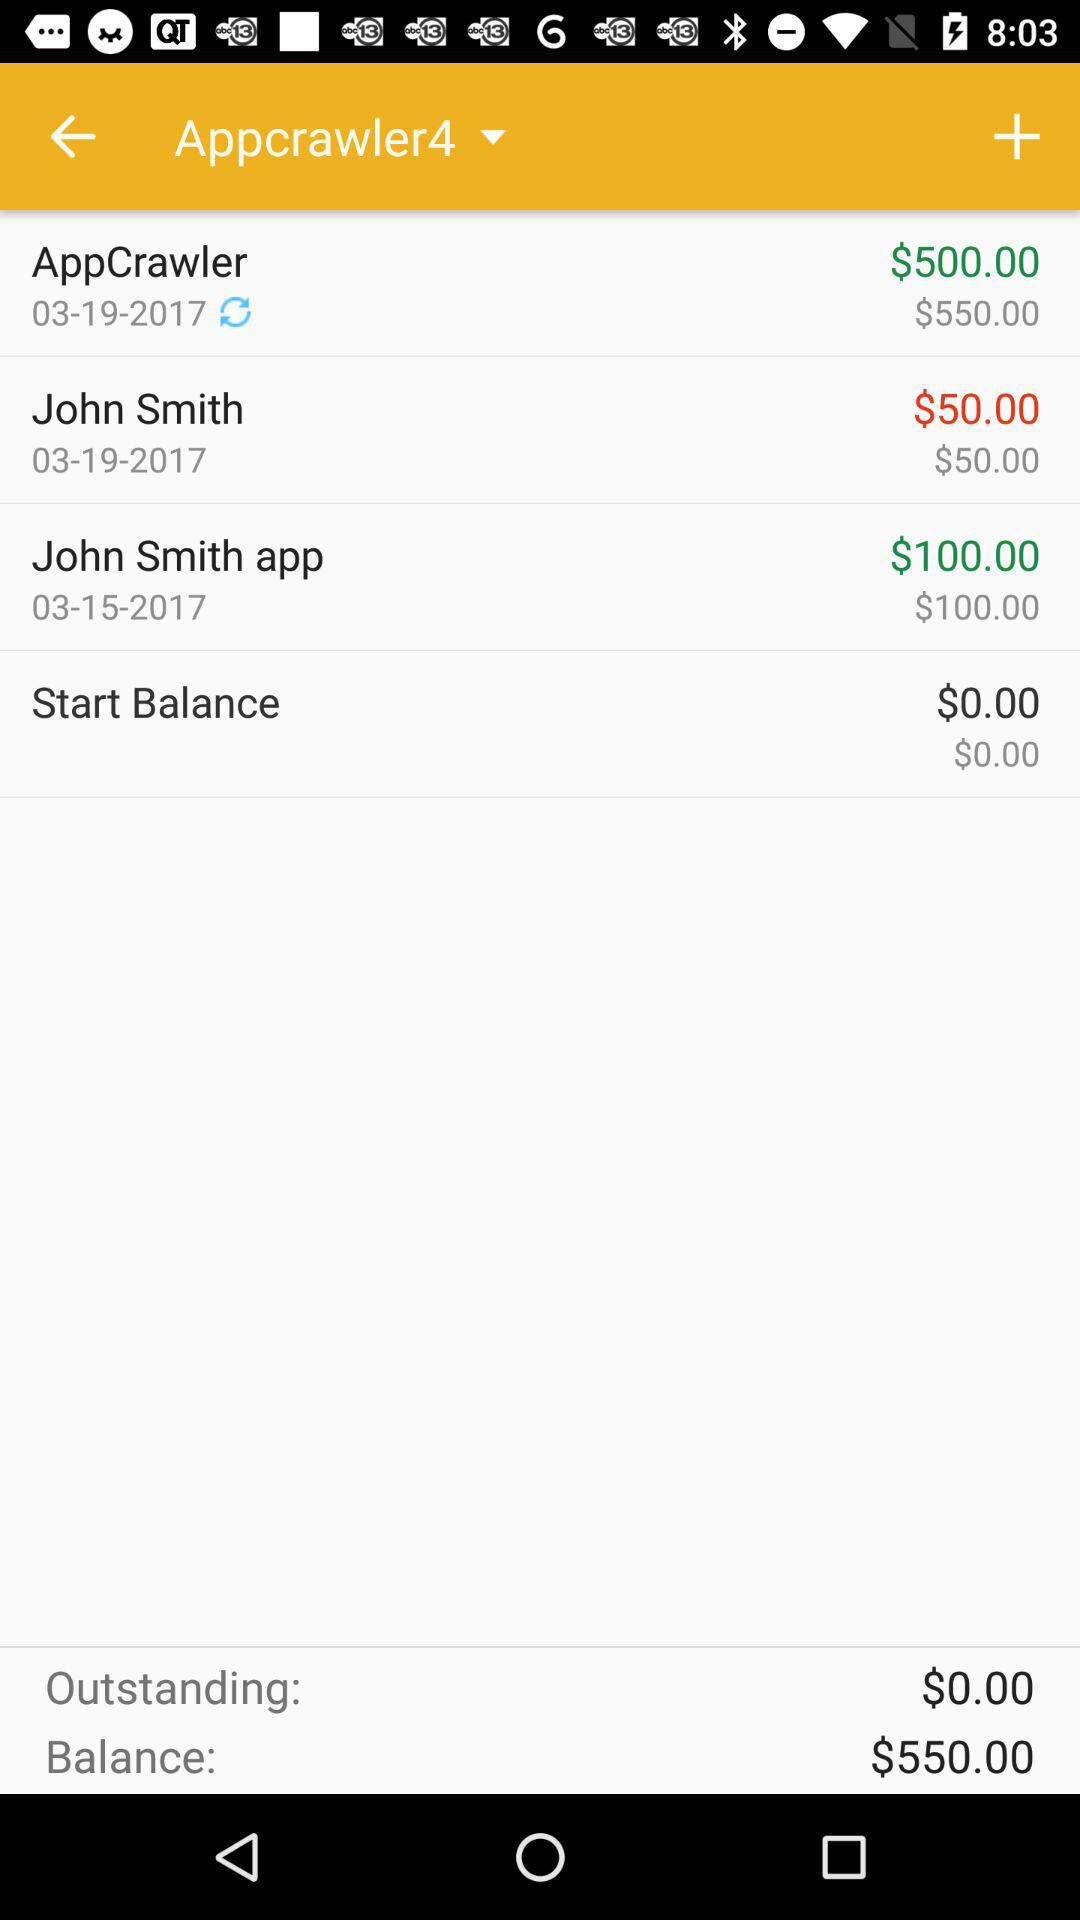What's the outstanding balance? The outstanding balance is $0. 